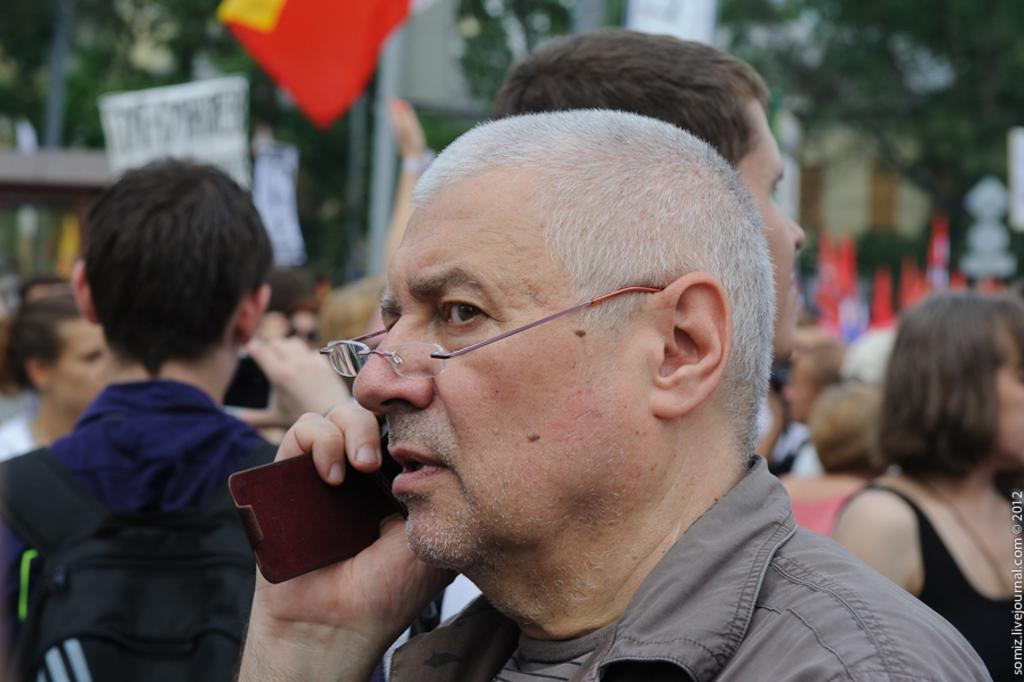How many people are in the image? There are persons in the image, but the exact number is not specified. What can be seen in the image besides the persons? There is an object in the image. What is visible in the background of the image? There are trees, a flag, and other objects in the background of the image. Is there any additional information about the image itself? Yes, there is a watermark on the image. Are there any babies celebrating a birthday in the image? There is no mention of babies or a birthday celebration in the image. The image contains persons, an object, and a background with trees, a flag, and other objects. 